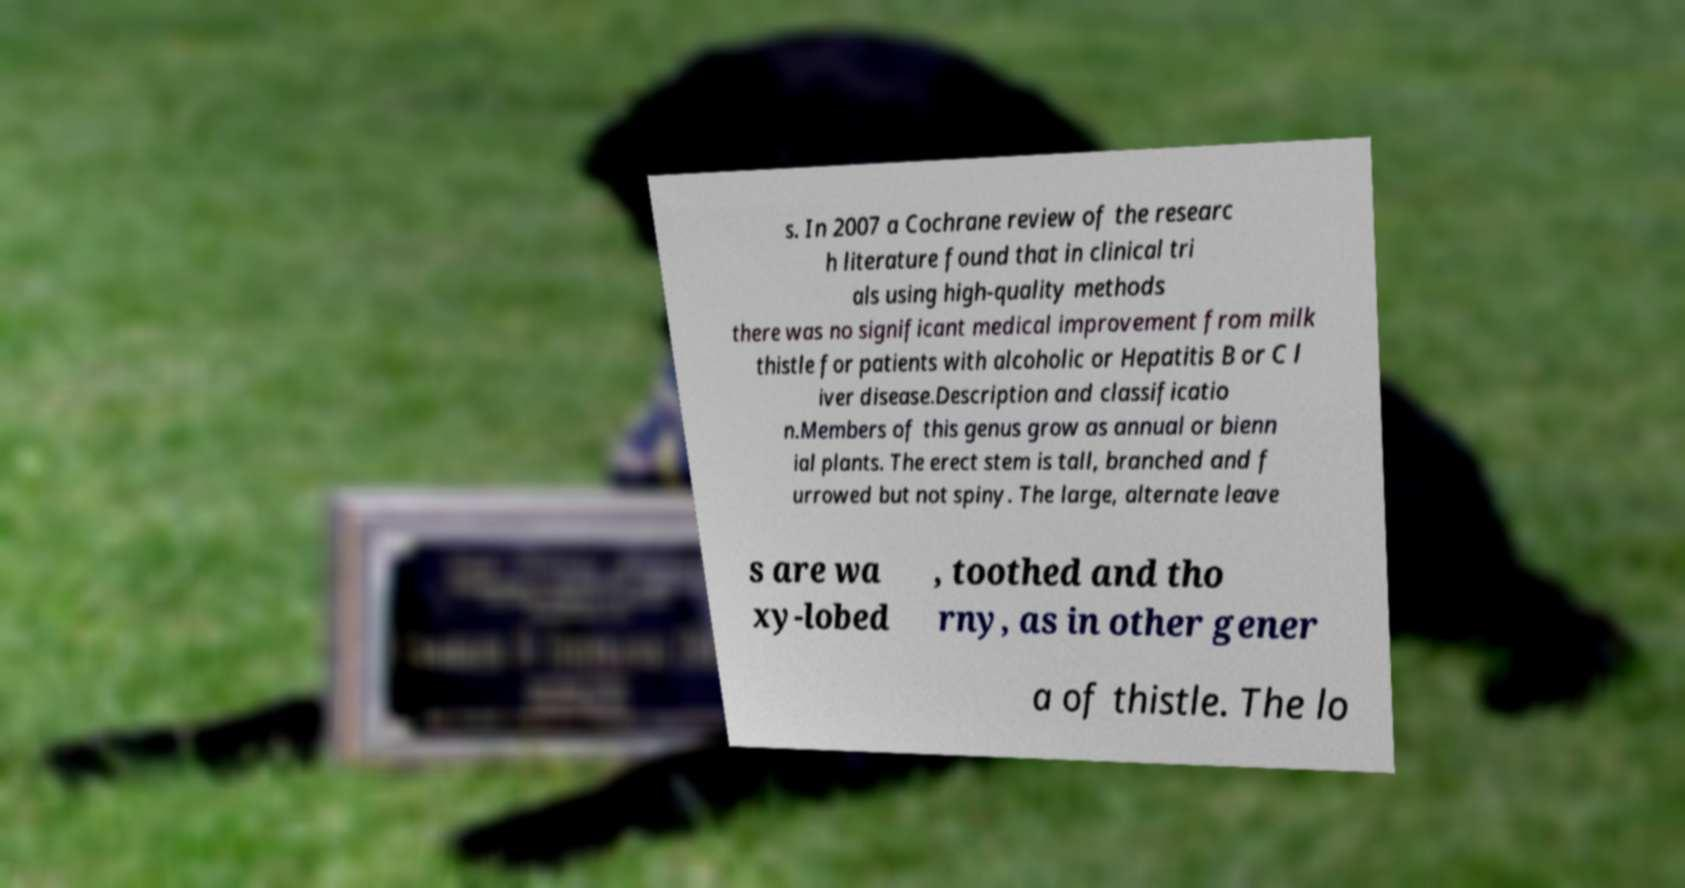For documentation purposes, I need the text within this image transcribed. Could you provide that? s. In 2007 a Cochrane review of the researc h literature found that in clinical tri als using high-quality methods there was no significant medical improvement from milk thistle for patients with alcoholic or Hepatitis B or C l iver disease.Description and classificatio n.Members of this genus grow as annual or bienn ial plants. The erect stem is tall, branched and f urrowed but not spiny. The large, alternate leave s are wa xy-lobed , toothed and tho rny, as in other gener a of thistle. The lo 